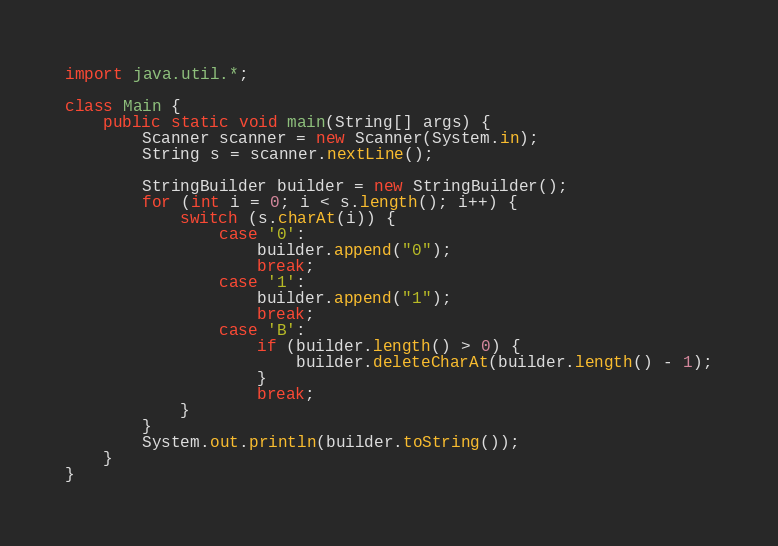Convert code to text. <code><loc_0><loc_0><loc_500><loc_500><_Java_>import java.util.*;

class Main {
    public static void main(String[] args) {
        Scanner scanner = new Scanner(System.in);
        String s = scanner.nextLine();

        StringBuilder builder = new StringBuilder();
        for (int i = 0; i < s.length(); i++) {
            switch (s.charAt(i)) {
                case '0':
                    builder.append("0");
                    break;
                case '1':
                    builder.append("1");
                    break;
                case 'B':
                    if (builder.length() > 0) {
                        builder.deleteCharAt(builder.length() - 1);
                    }
                    break;
            }
        }
        System.out.println(builder.toString());
    }
}
</code> 